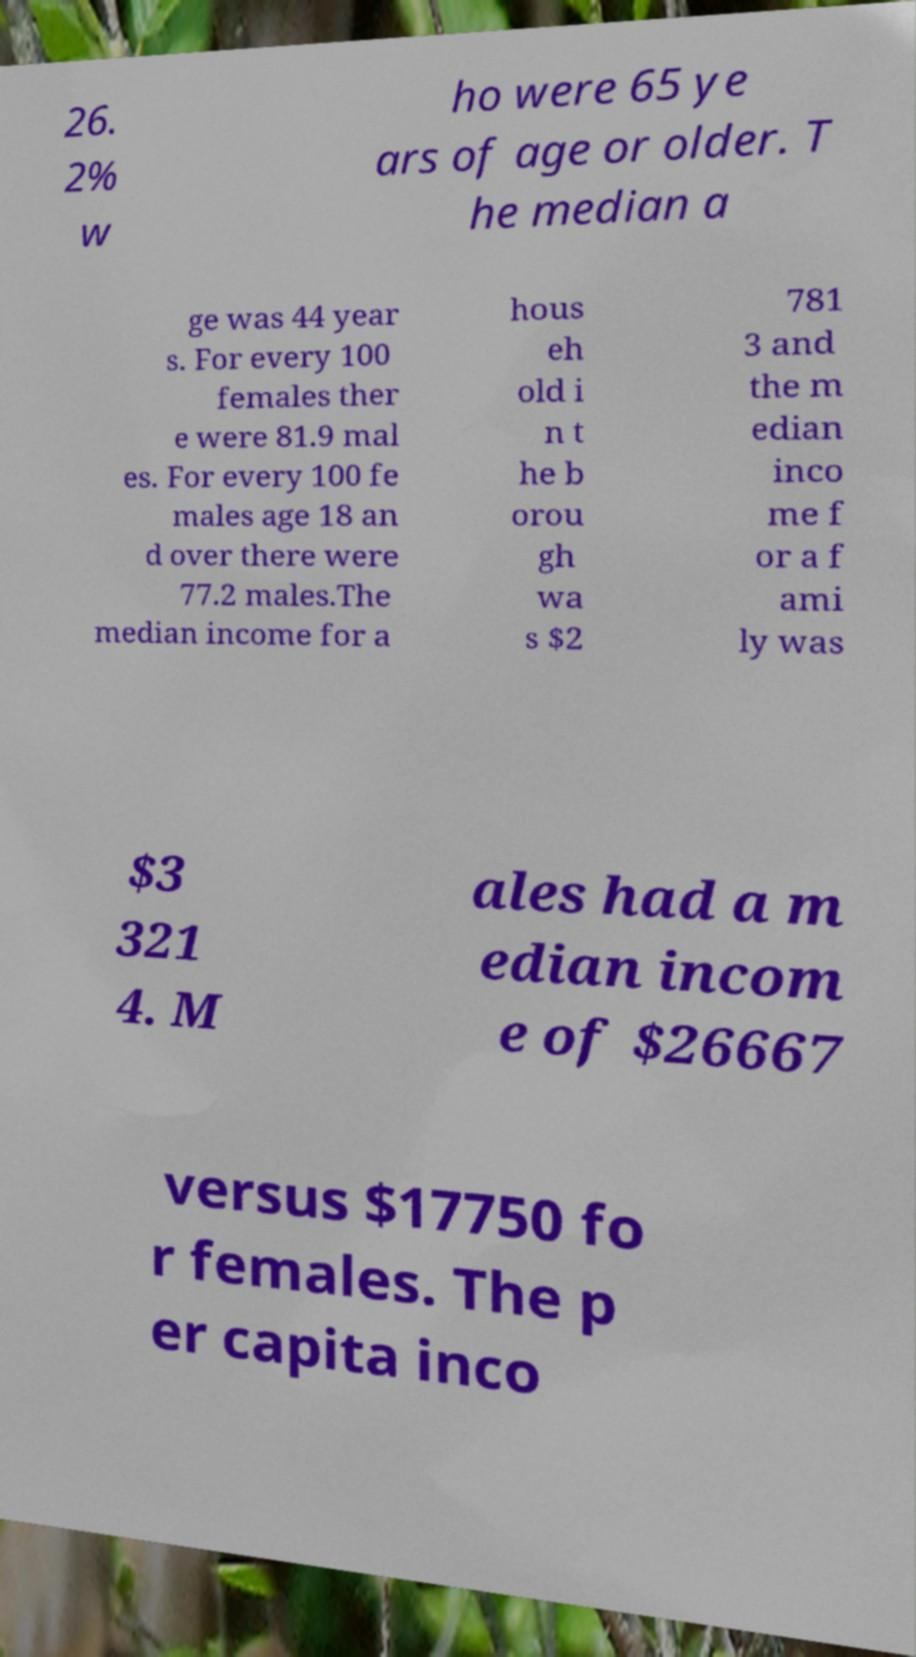Please identify and transcribe the text found in this image. 26. 2% w ho were 65 ye ars of age or older. T he median a ge was 44 year s. For every 100 females ther e were 81.9 mal es. For every 100 fe males age 18 an d over there were 77.2 males.The median income for a hous eh old i n t he b orou gh wa s $2 781 3 and the m edian inco me f or a f ami ly was $3 321 4. M ales had a m edian incom e of $26667 versus $17750 fo r females. The p er capita inco 